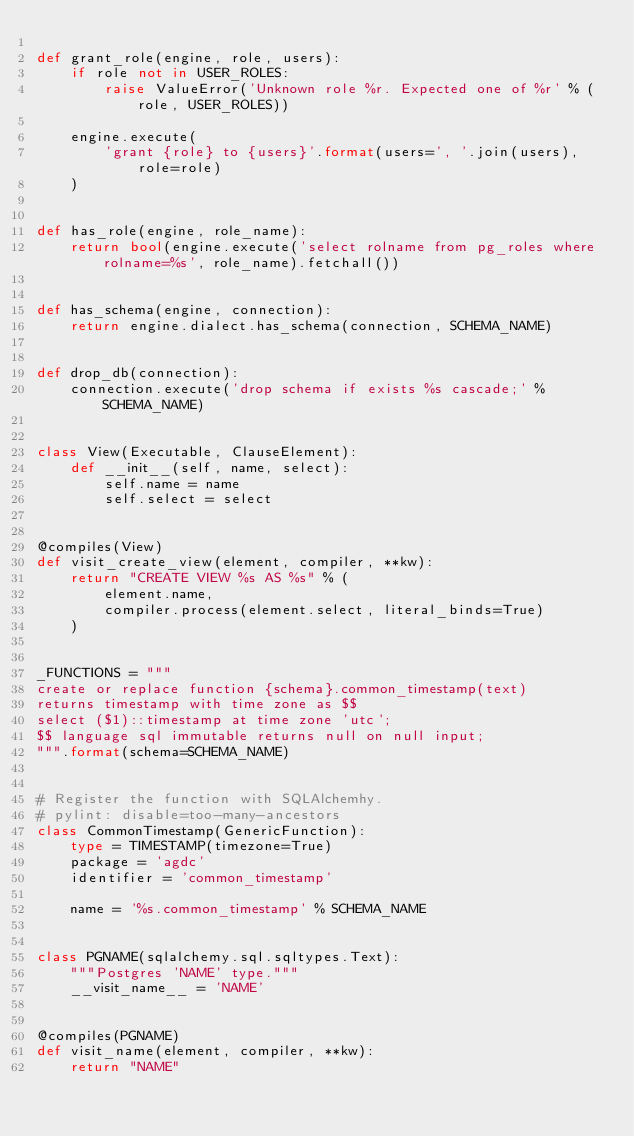Convert code to text. <code><loc_0><loc_0><loc_500><loc_500><_Python_>
def grant_role(engine, role, users):
    if role not in USER_ROLES:
        raise ValueError('Unknown role %r. Expected one of %r' % (role, USER_ROLES))

    engine.execute(
        'grant {role} to {users}'.format(users=', '.join(users), role=role)
    )


def has_role(engine, role_name):
    return bool(engine.execute('select rolname from pg_roles where rolname=%s', role_name).fetchall())


def has_schema(engine, connection):
    return engine.dialect.has_schema(connection, SCHEMA_NAME)


def drop_db(connection):
    connection.execute('drop schema if exists %s cascade;' % SCHEMA_NAME)


class View(Executable, ClauseElement):
    def __init__(self, name, select):
        self.name = name
        self.select = select


@compiles(View)
def visit_create_view(element, compiler, **kw):
    return "CREATE VIEW %s AS %s" % (
        element.name,
        compiler.process(element.select, literal_binds=True)
    )


_FUNCTIONS = """
create or replace function {schema}.common_timestamp(text)
returns timestamp with time zone as $$
select ($1)::timestamp at time zone 'utc';
$$ language sql immutable returns null on null input;
""".format(schema=SCHEMA_NAME)


# Register the function with SQLAlchemhy.
# pylint: disable=too-many-ancestors
class CommonTimestamp(GenericFunction):
    type = TIMESTAMP(timezone=True)
    package = 'agdc'
    identifier = 'common_timestamp'

    name = '%s.common_timestamp' % SCHEMA_NAME


class PGNAME(sqlalchemy.sql.sqltypes.Text):
    """Postgres 'NAME' type."""
    __visit_name__ = 'NAME'


@compiles(PGNAME)
def visit_name(element, compiler, **kw):
    return "NAME"
</code> 